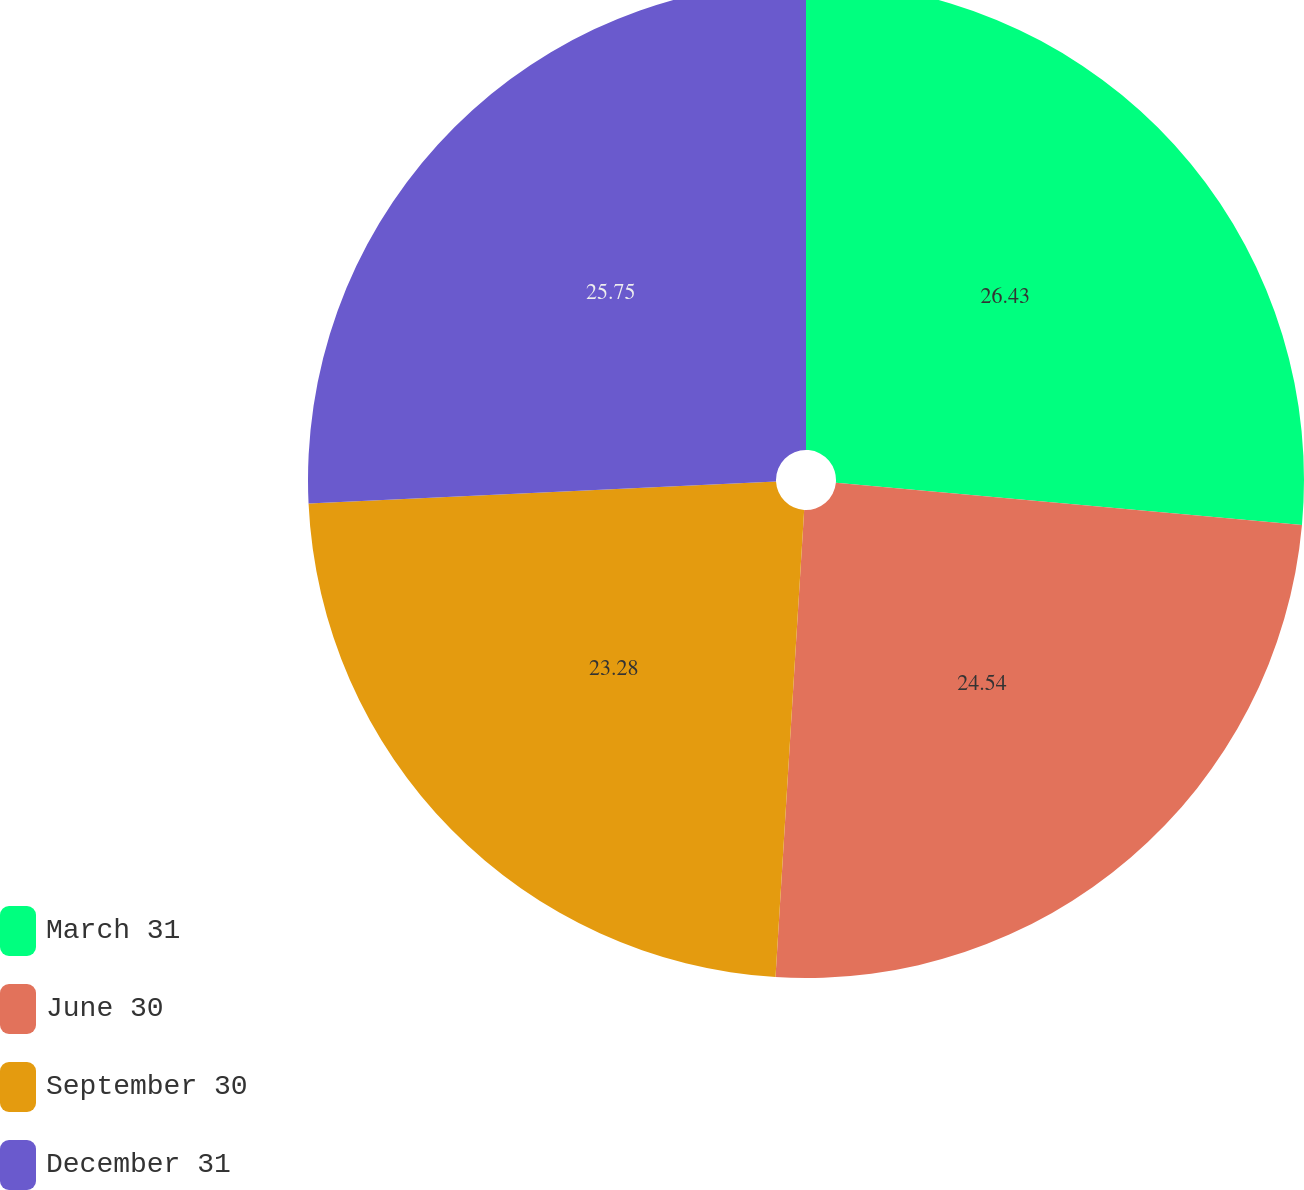<chart> <loc_0><loc_0><loc_500><loc_500><pie_chart><fcel>March 31<fcel>June 30<fcel>September 30<fcel>December 31<nl><fcel>26.44%<fcel>24.54%<fcel>23.28%<fcel>25.75%<nl></chart> 